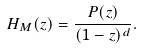Convert formula to latex. <formula><loc_0><loc_0><loc_500><loc_500>H _ { M } ( z ) = \frac { P ( z ) } { ( 1 - z ) ^ { d } } .</formula> 